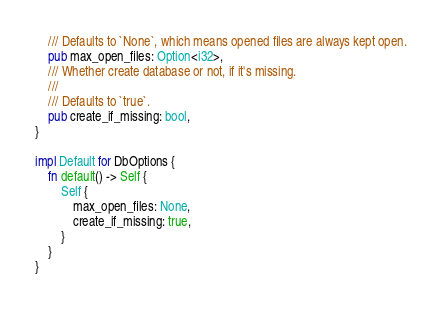Convert code to text. <code><loc_0><loc_0><loc_500><loc_500><_Rust_>    /// Defaults to `None`, which means opened files are always kept open.
    pub max_open_files: Option<i32>,
    /// Whether create database or not, if it's missing.
    ///
    /// Defaults to `true`.
    pub create_if_missing: bool,
}

impl Default for DbOptions {
    fn default() -> Self {
        Self {
            max_open_files: None,
            create_if_missing: true,
        }
    }
}
</code> 